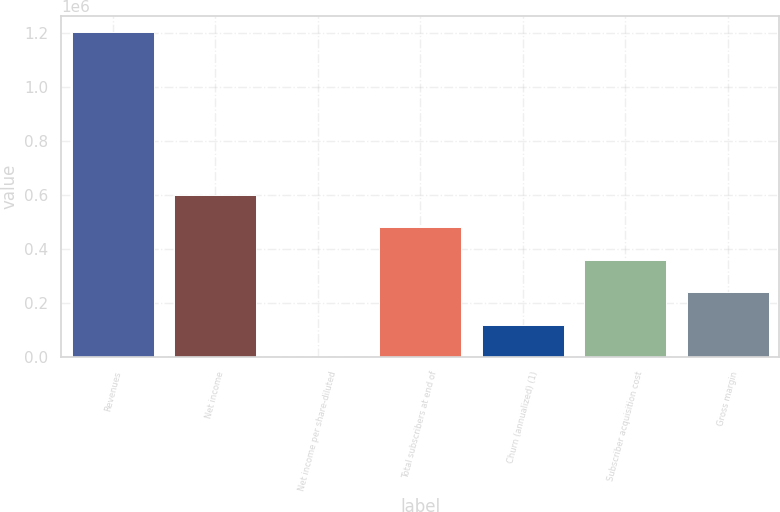Convert chart to OTSL. <chart><loc_0><loc_0><loc_500><loc_500><bar_chart><fcel>Revenues<fcel>Net income<fcel>Net income per share-diluted<fcel>Total subscribers at end of<fcel>Churn (annualized) (1)<fcel>Subscriber acquisition cost<fcel>Gross margin<nl><fcel>1.20534e+06<fcel>602670<fcel>0.97<fcel>482137<fcel>120535<fcel>361603<fcel>241069<nl></chart> 